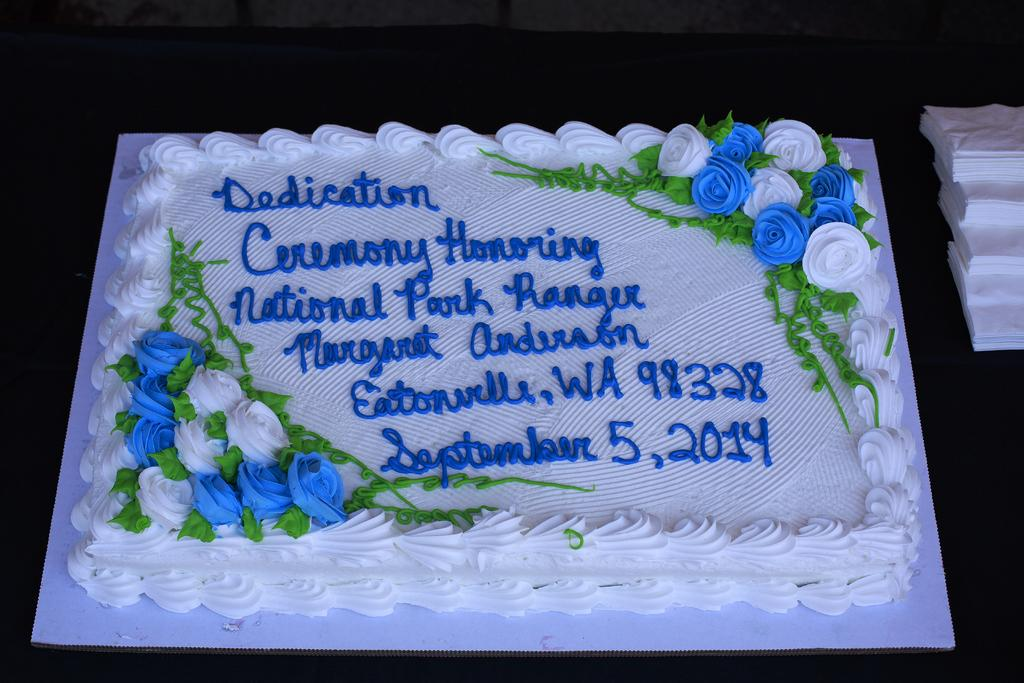What is on the tray in the image? There is a cake on the tray in the image. What else can be seen on the tray besides the cake? There are no other items visible on the tray besides the cake. What is covering the black surface in the image? Tissue papers are present on the black surface in the image. What is written on the cake? Something is written on the cake, but the specific message cannot be determined from the image. What type of gold is visible on the train in the image? There is no train or gold present in the image. What is the tin used for in the image? There is no tin present in the image. 